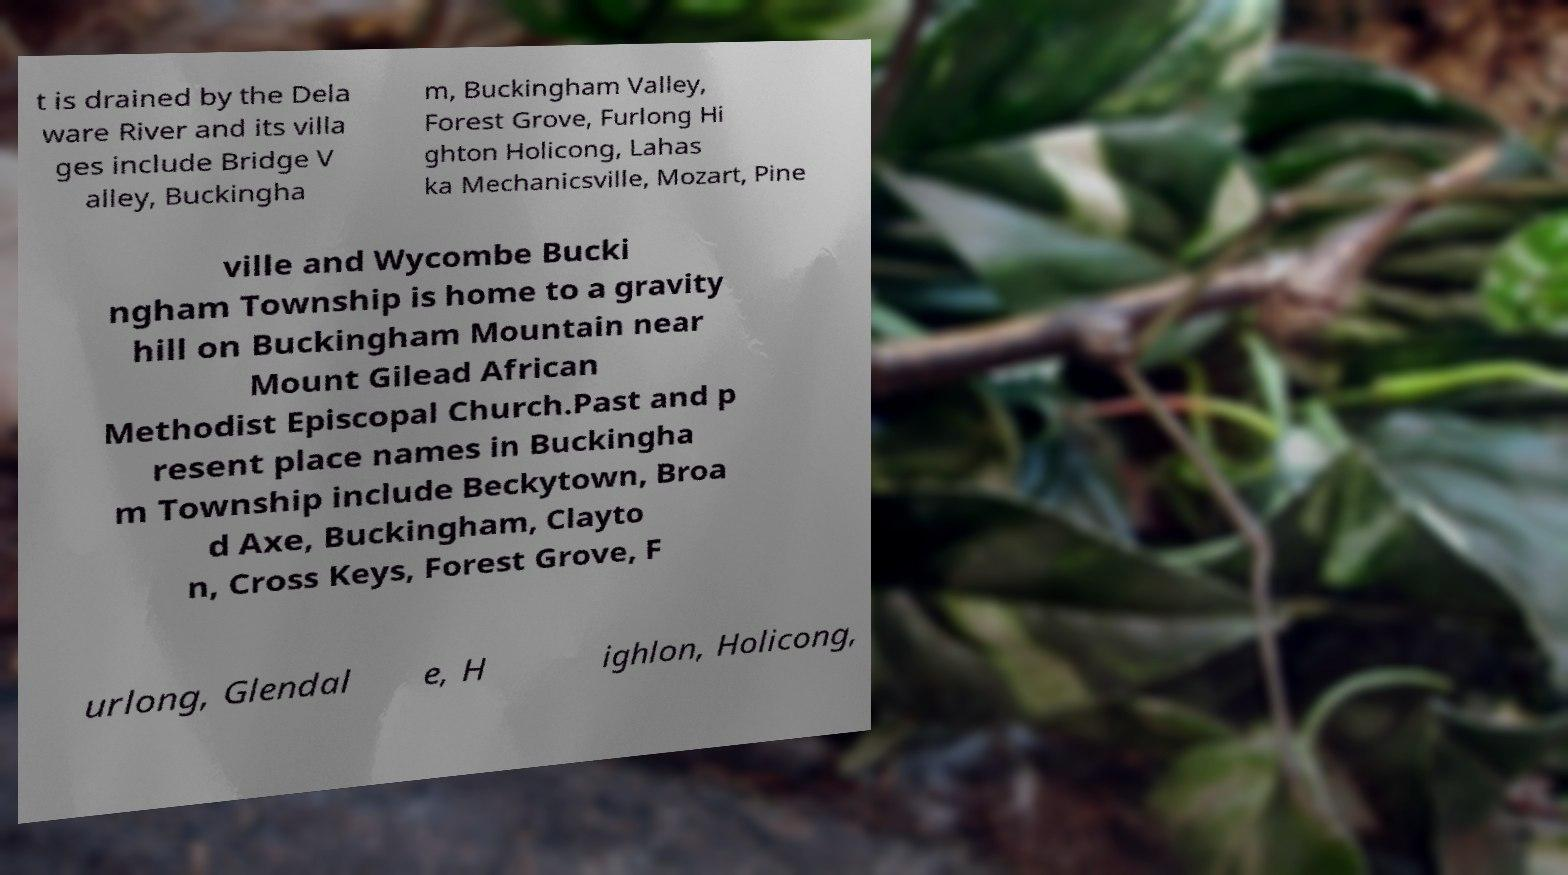I need the written content from this picture converted into text. Can you do that? t is drained by the Dela ware River and its villa ges include Bridge V alley, Buckingha m, Buckingham Valley, Forest Grove, Furlong Hi ghton Holicong, Lahas ka Mechanicsville, Mozart, Pine ville and Wycombe Bucki ngham Township is home to a gravity hill on Buckingham Mountain near Mount Gilead African Methodist Episcopal Church.Past and p resent place names in Buckingha m Township include Beckytown, Broa d Axe, Buckingham, Clayto n, Cross Keys, Forest Grove, F urlong, Glendal e, H ighlon, Holicong, 